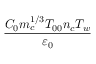Convert formula to latex. <formula><loc_0><loc_0><loc_500><loc_500>\frac { C _ { 0 } m _ { c } ^ { 1 / 3 } T _ { 0 0 } n _ { c } T _ { w } } { { \varepsilon } _ { 0 } }</formula> 